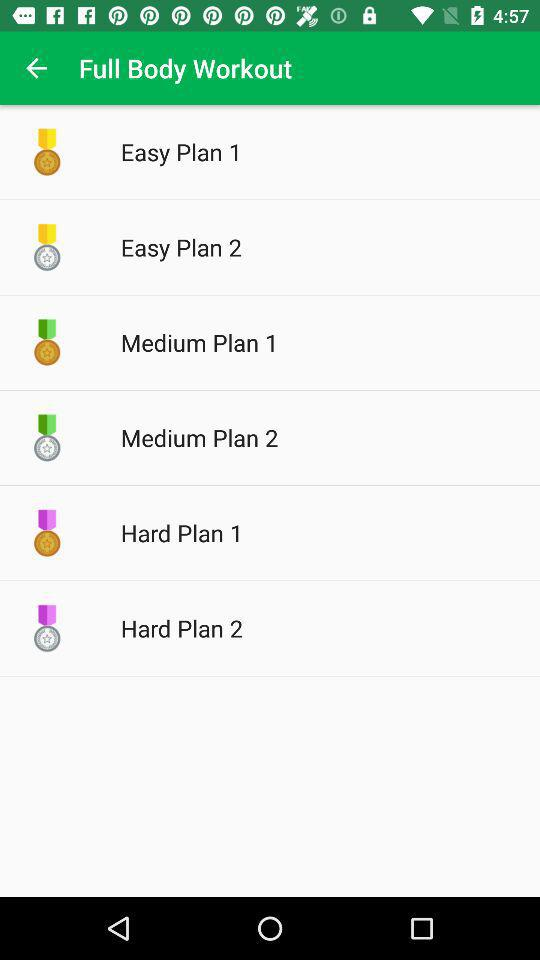What is the application name? The application name is "Full Body Workout". 